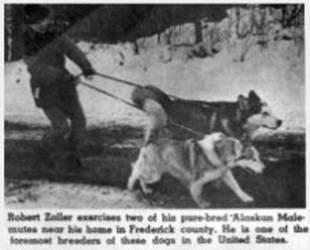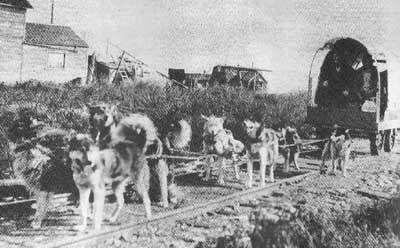The first image is the image on the left, the second image is the image on the right. Examine the images to the left and right. Is the description "In at least one image there is a single person facing forward holding their huskey in the snow." accurate? Answer yes or no. No. The first image is the image on the left, the second image is the image on the right. For the images displayed, is the sentence "An image shows a forward-facing person wearing fur, posing next to at least one forward-facing sled dog." factually correct? Answer yes or no. No. 